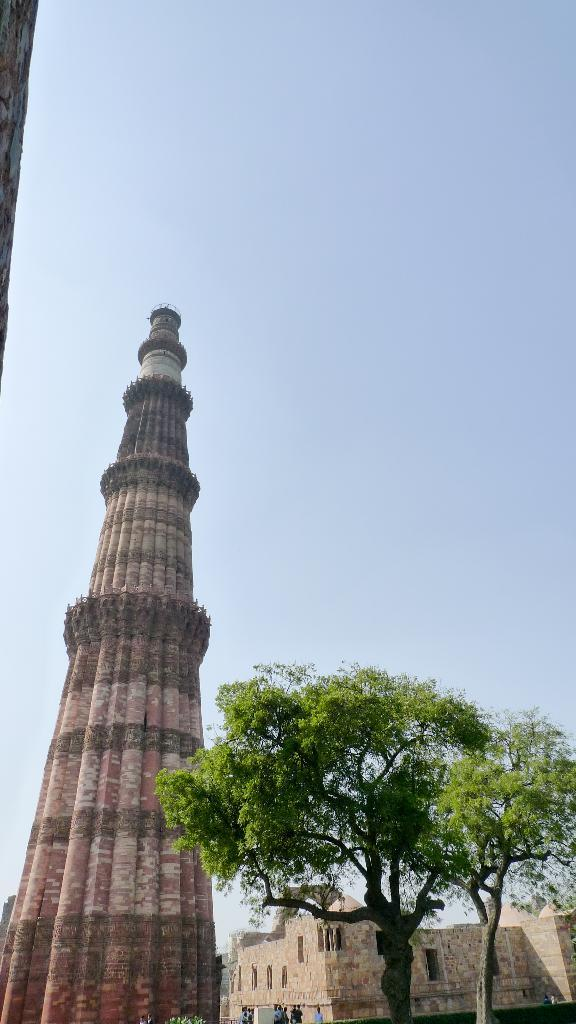What structure is located on the left side of the image? There is a pillar on the left side of the image. What type of man-made structure can be seen in the image? There is a building in the image. What type of natural vegetation is visible in the image? There are trees visible in the image. What is visible at the top of the image? The sky is visible at the top of the image. How does the pillar act as a cent in the image? The pillar does not act as a cent in the image; it is a stationary structure. What afterthought is depicted in the image? There is no afterthought depicted in the image; it features a pillar, a building, trees, and the sky. 